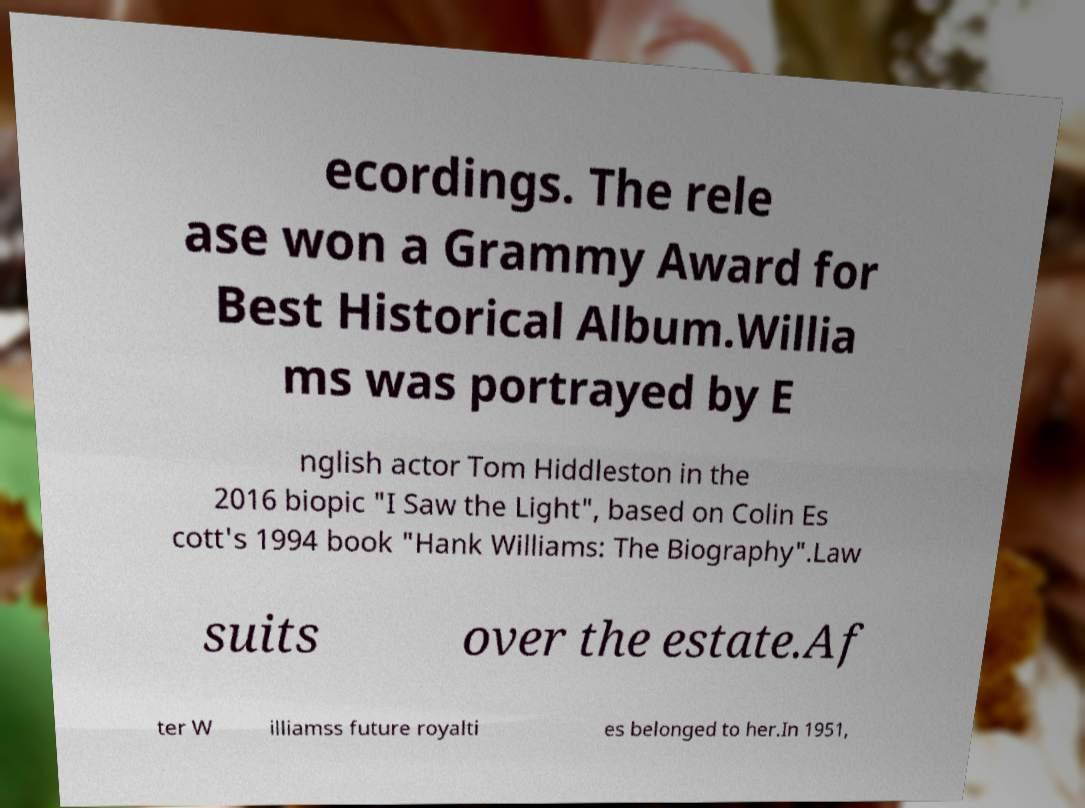Could you extract and type out the text from this image? ecordings. The rele ase won a Grammy Award for Best Historical Album.Willia ms was portrayed by E nglish actor Tom Hiddleston in the 2016 biopic "I Saw the Light", based on Colin Es cott's 1994 book "Hank Williams: The Biography".Law suits over the estate.Af ter W illiamss future royalti es belonged to her.In 1951, 